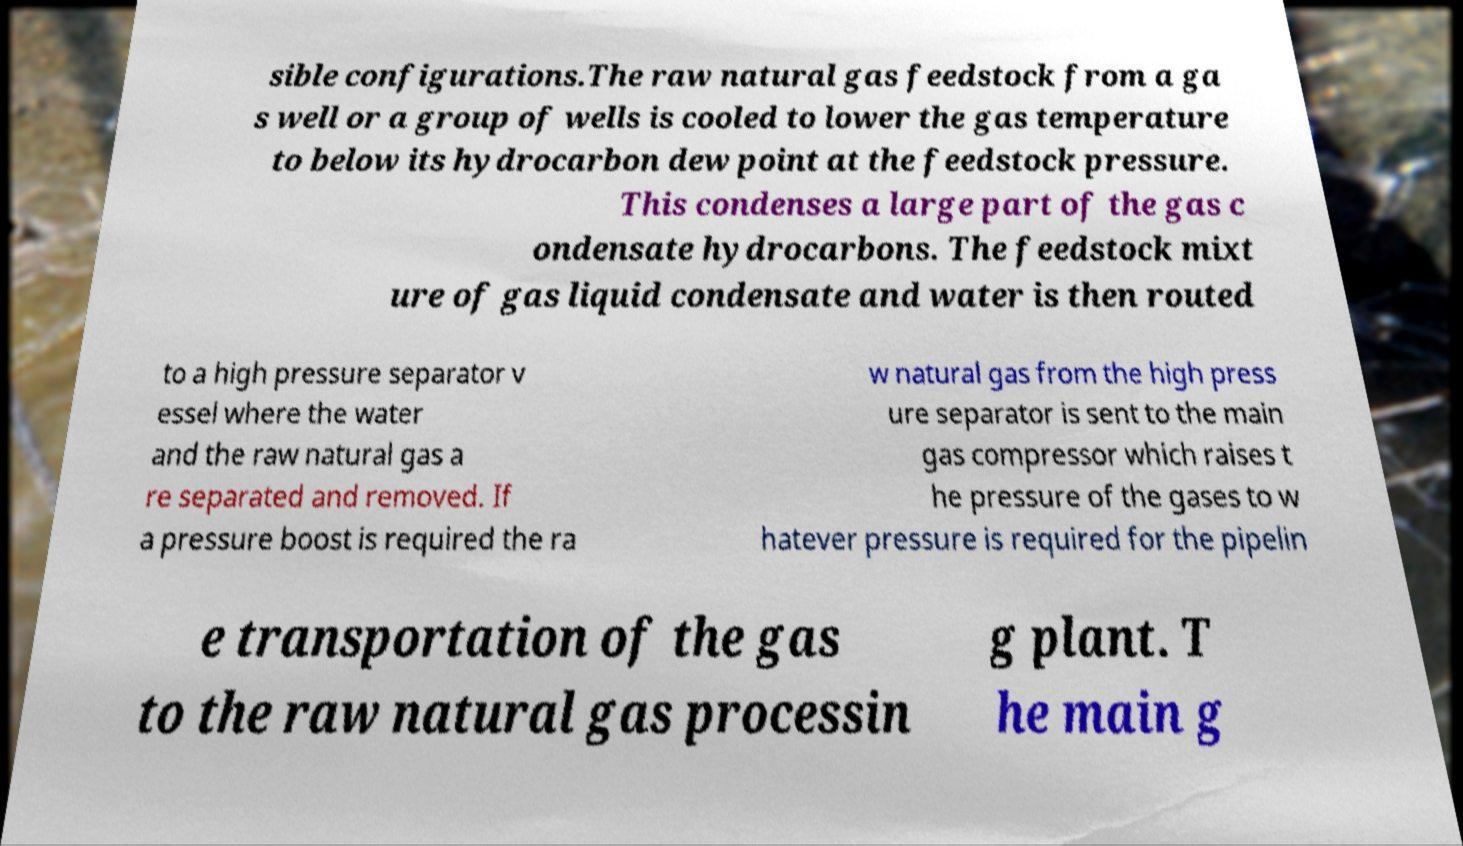Please read and relay the text visible in this image. What does it say? sible configurations.The raw natural gas feedstock from a ga s well or a group of wells is cooled to lower the gas temperature to below its hydrocarbon dew point at the feedstock pressure. This condenses a large part of the gas c ondensate hydrocarbons. The feedstock mixt ure of gas liquid condensate and water is then routed to a high pressure separator v essel where the water and the raw natural gas a re separated and removed. If a pressure boost is required the ra w natural gas from the high press ure separator is sent to the main gas compressor which raises t he pressure of the gases to w hatever pressure is required for the pipelin e transportation of the gas to the raw natural gas processin g plant. T he main g 